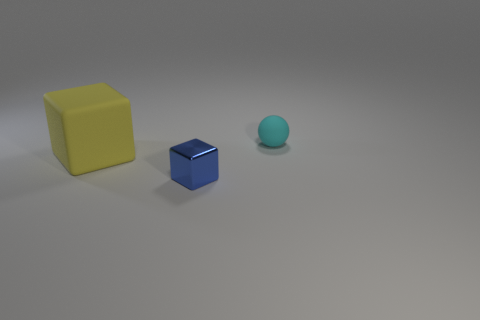Add 3 gray metal cylinders. How many objects exist? 6 Subtract all blocks. How many objects are left? 1 Subtract all big cyan rubber objects. Subtract all small spheres. How many objects are left? 2 Add 3 balls. How many balls are left? 4 Add 3 small yellow matte cylinders. How many small yellow matte cylinders exist? 3 Subtract 0 yellow balls. How many objects are left? 3 